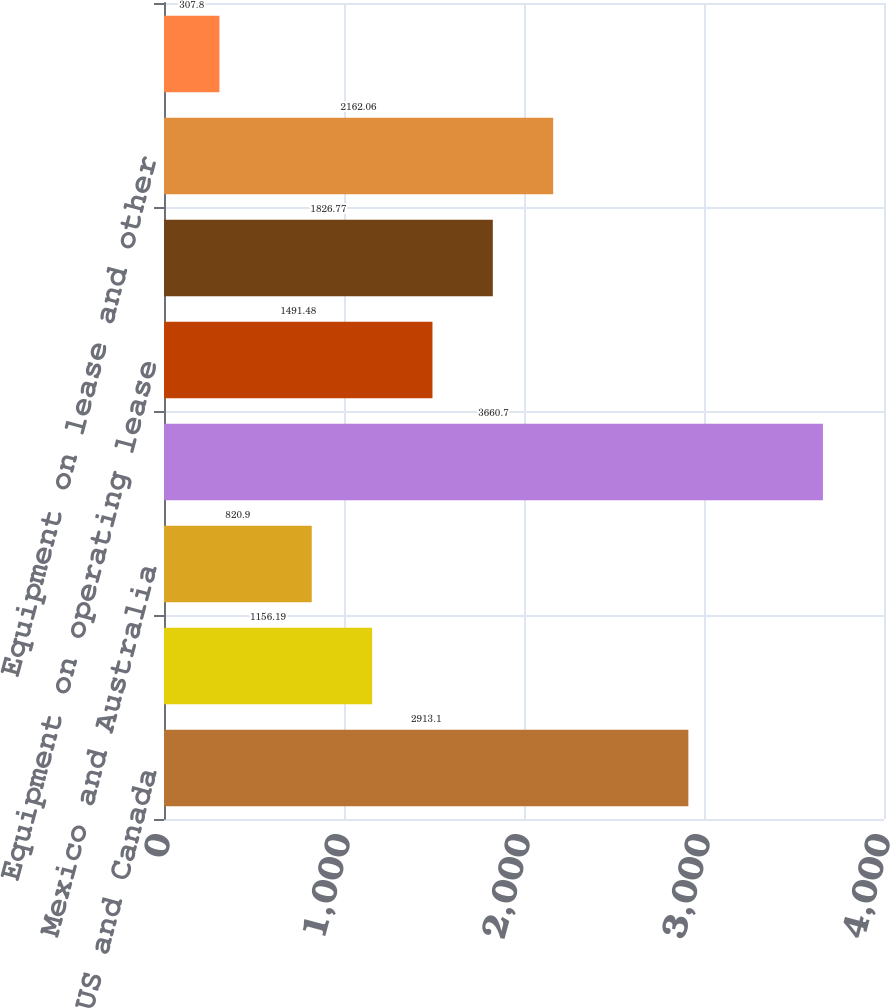<chart> <loc_0><loc_0><loc_500><loc_500><bar_chart><fcel>US and Canada<fcel>Europe<fcel>Mexico and Australia<fcel>Loans and finance leases<fcel>Equipment on operating lease<fcel>Dealer wholesale financing<fcel>Equipment on lease and other<fcel>Income before income taxes<nl><fcel>2913.1<fcel>1156.19<fcel>820.9<fcel>3660.7<fcel>1491.48<fcel>1826.77<fcel>2162.06<fcel>307.8<nl></chart> 